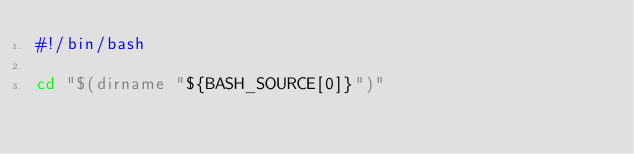<code> <loc_0><loc_0><loc_500><loc_500><_Bash_>#!/bin/bash

cd "$(dirname "${BASH_SOURCE[0]}")"
</code> 